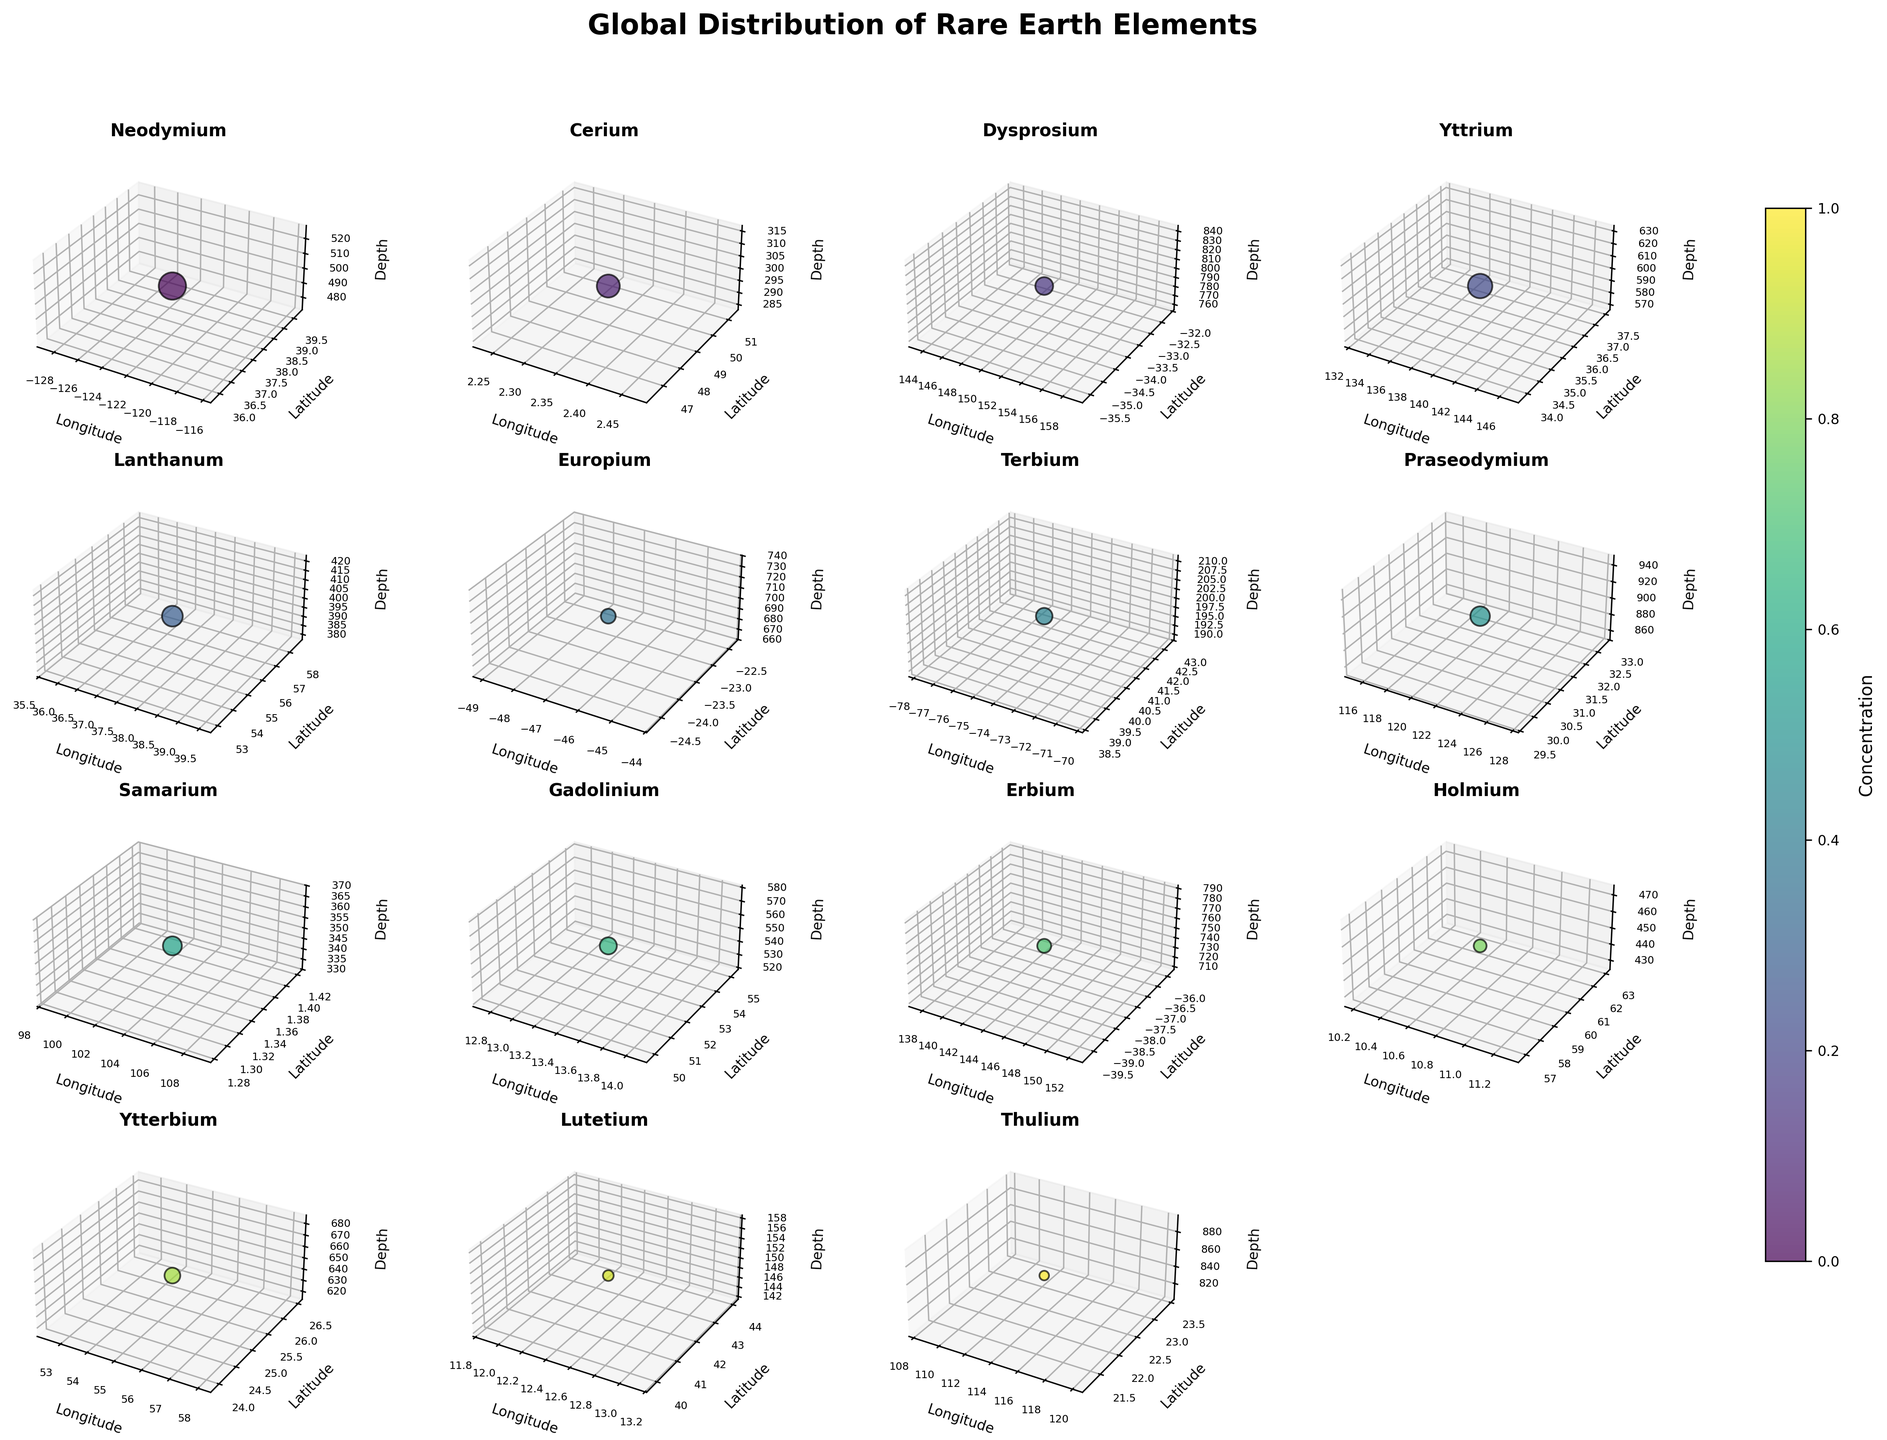What's the title of the figure? Look at the top of the figure. The title is usually displayed there.
Answer: Global Distribution of Rare Earth Elements Which element has the deepest depth in its subplot? Examine each subplot's z-axis (Depth). The deepest depth is the highest numeric value. Praseodymium's deepest depth is 900.
Answer: Praseodymium How are the concentrations visually represented in the subplots? Concentrations are depicted by the size of the scatter points. Larger points indicate higher concentrations.
Answer: By the size of the scatter points Which elements have higher concentrations, Neodymium or Cerium? Compare the size of the scatter points for Neodymium and Cerium in their respective subplots. Neodymium has larger scatter points than Cerium.
Answer: Neodymium What's the longitude location of Ytterbium's data point? Look at Ytterbium’s subplot and check the x-axis (Longitude). The longitude value is 55.2708.
Answer: 55.2708 Which element has the smallest concentration? Compare all subplots' scatter point sizes. Thulium has the smallest scatter points, indicating the lowest concentration.
Answer: Thulium What is the commonality in the axis labels for all elements? Go through each subplot and observe the labels on the axes (x, y, z). They all share the same labels: Longitude (x), Latitude (y), and Depth (z).
Answer: Longitude, Latitude, Depth What color palette is used for shading the points? Identify the color scheme consistent across all subplots. The viridis color map is utilized for shading.
Answer: Viridis color map How does the depth of Europium compare to Dysprosium? Check the z-axis (Depth) in Europium’s and Dysprosium’s subplots. Europium has a depth of 700, while Dysprosium has a depth of 800. Europium’s depth is less than Dysprosium’s.
Answer: Europium's depth is less than Dysprosium's Which elements are located in the Southern Hemisphere? Look at the latitude values of all the subplots. The Southern Hemisphere has negative latitude values. Dysprosium, Europium, and Erbium are in the Southern Hemisphere.
Answer: Dysprosium, Europium, and Erbium 